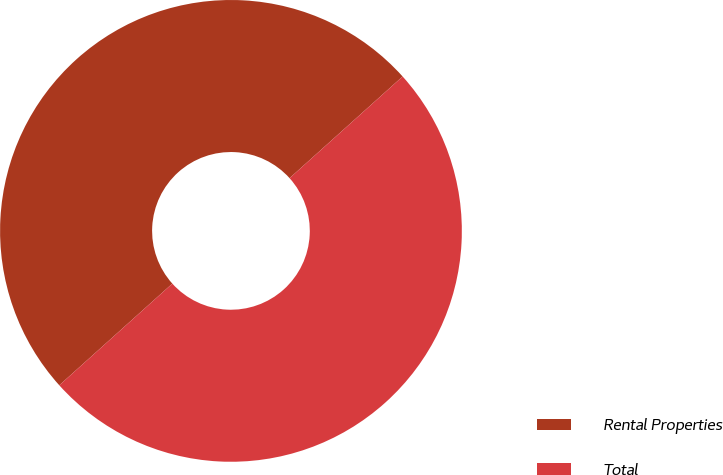Convert chart to OTSL. <chart><loc_0><loc_0><loc_500><loc_500><pie_chart><fcel>Rental Properties<fcel>Total<nl><fcel>50.0%<fcel>50.0%<nl></chart> 